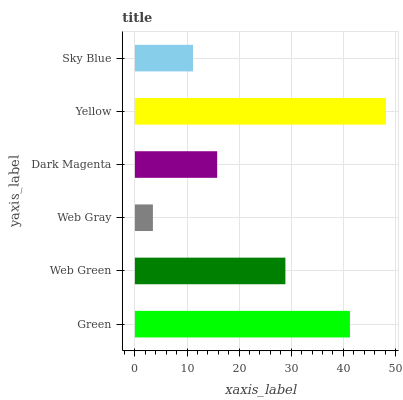Is Web Gray the minimum?
Answer yes or no. Yes. Is Yellow the maximum?
Answer yes or no. Yes. Is Web Green the minimum?
Answer yes or no. No. Is Web Green the maximum?
Answer yes or no. No. Is Green greater than Web Green?
Answer yes or no. Yes. Is Web Green less than Green?
Answer yes or no. Yes. Is Web Green greater than Green?
Answer yes or no. No. Is Green less than Web Green?
Answer yes or no. No. Is Web Green the high median?
Answer yes or no. Yes. Is Dark Magenta the low median?
Answer yes or no. Yes. Is Web Gray the high median?
Answer yes or no. No. Is Sky Blue the low median?
Answer yes or no. No. 